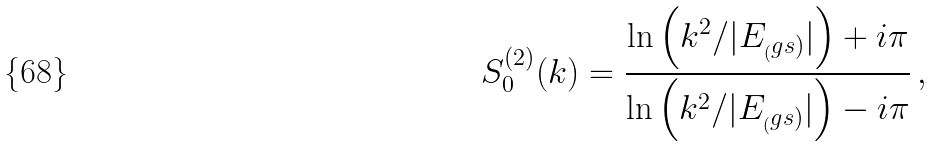Convert formula to latex. <formula><loc_0><loc_0><loc_500><loc_500>S _ { 0 } ^ { ( 2 ) } ( k ) = \frac { \ln \left ( k ^ { 2 } / | E _ { _ { ( } g s ) } | \right ) + i \pi } { \ln \left ( k ^ { 2 } / | E _ { _ { ( } g s ) } | \right ) - i \pi } \, ,</formula> 